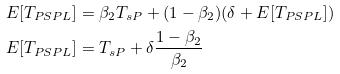<formula> <loc_0><loc_0><loc_500><loc_500>E [ T _ { P S P L } ] & = \beta _ { 2 } T _ { s P } + ( 1 - \beta _ { 2 } ) ( \delta + E [ T _ { P S P L } ] ) \\ E [ T _ { P S P L } ] & = T _ { s P } + \delta \frac { 1 - \beta _ { 2 } } { \beta _ { 2 } }</formula> 